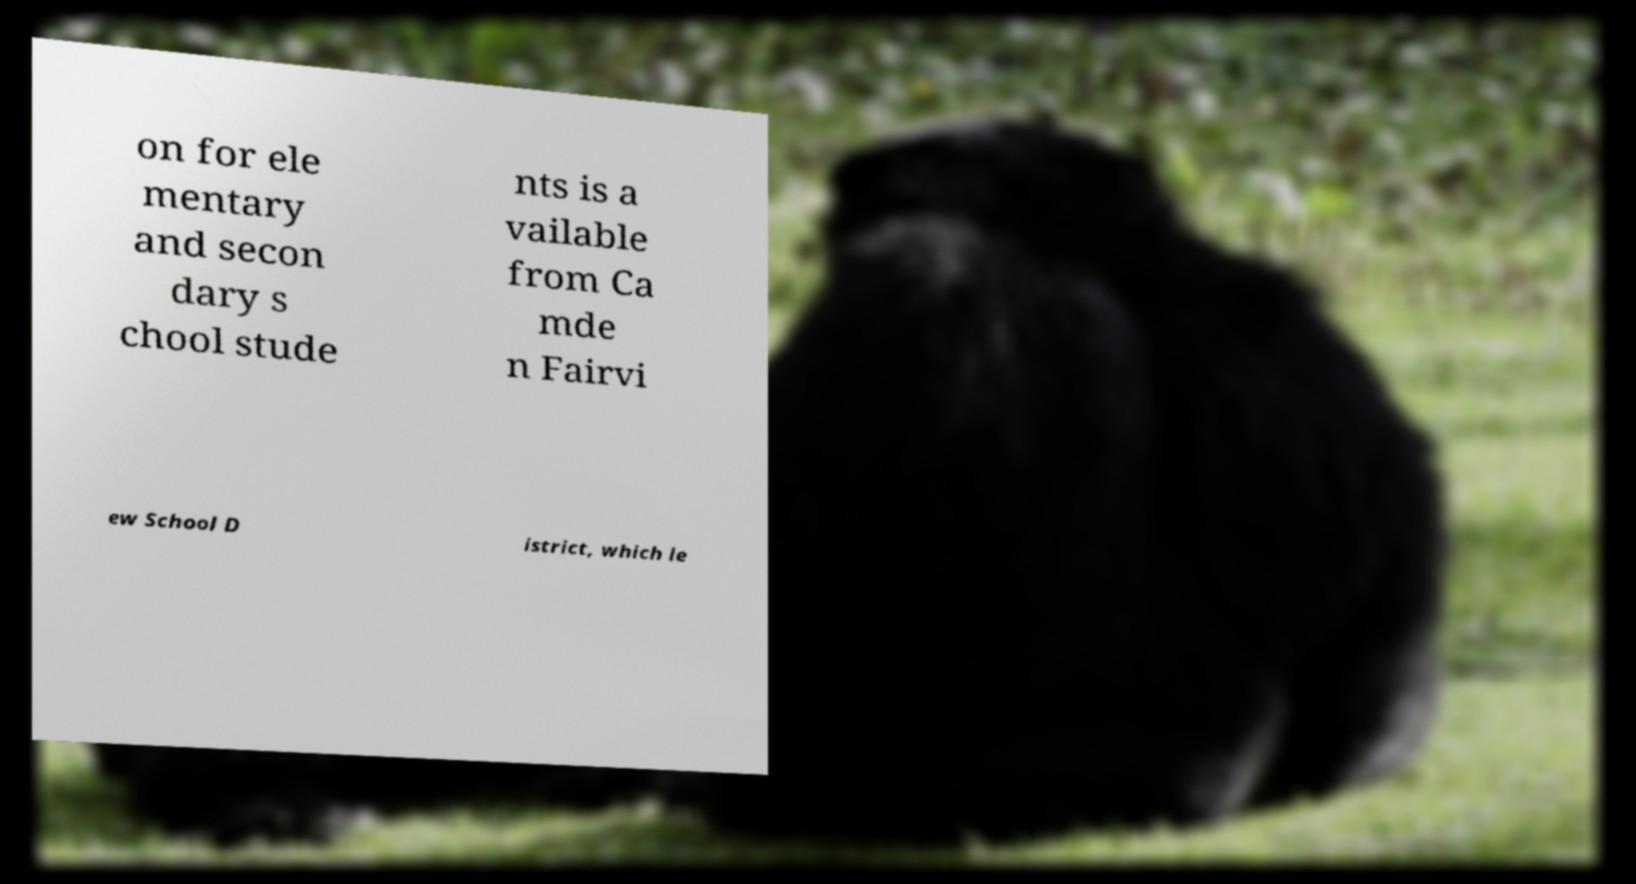Could you extract and type out the text from this image? on for ele mentary and secon dary s chool stude nts is a vailable from Ca mde n Fairvi ew School D istrict, which le 